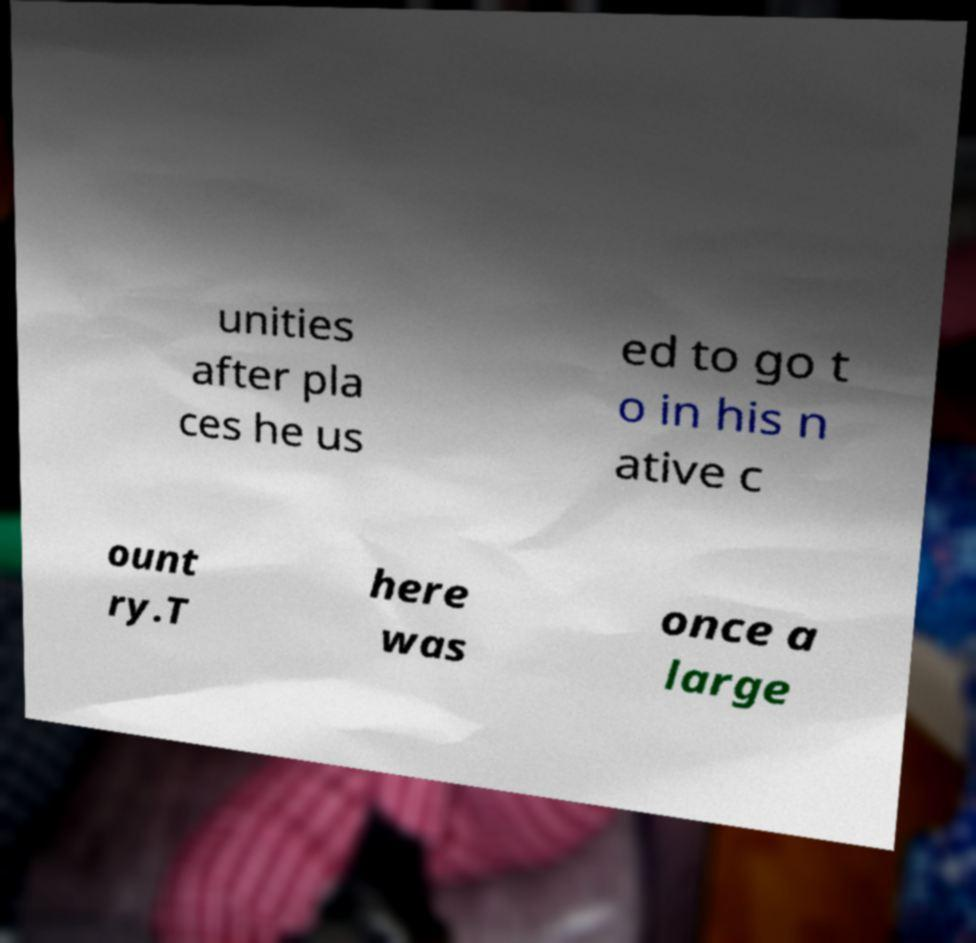Could you assist in decoding the text presented in this image and type it out clearly? unities after pla ces he us ed to go t o in his n ative c ount ry.T here was once a large 